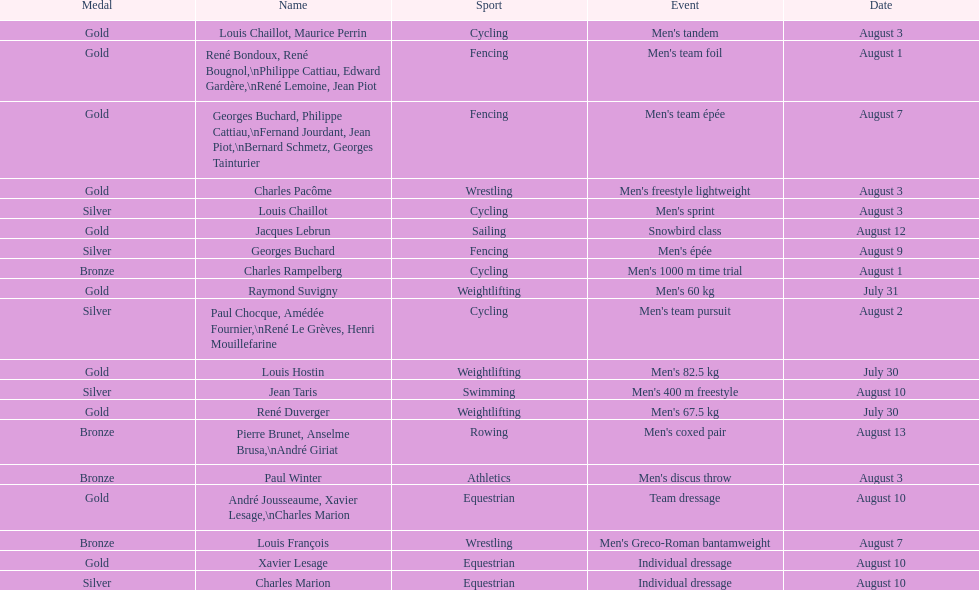How many medals were secured after august 3? 9. 